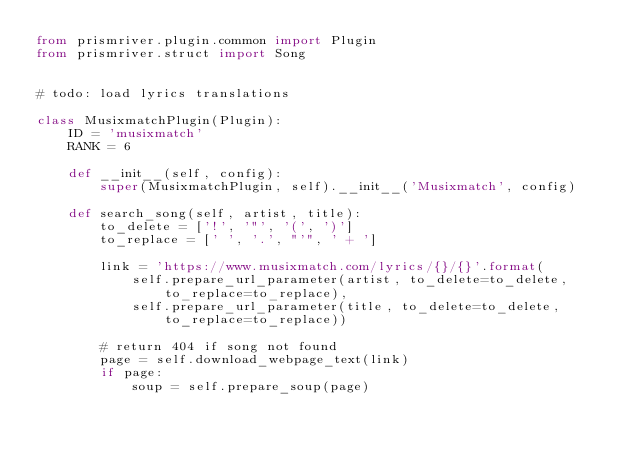Convert code to text. <code><loc_0><loc_0><loc_500><loc_500><_Python_>from prismriver.plugin.common import Plugin
from prismriver.struct import Song


# todo: load lyrics translations

class MusixmatchPlugin(Plugin):
    ID = 'musixmatch'
    RANK = 6

    def __init__(self, config):
        super(MusixmatchPlugin, self).__init__('Musixmatch', config)

    def search_song(self, artist, title):
        to_delete = ['!', '"', '(', ')']
        to_replace = [' ', '.', "'", ' + ']

        link = 'https://www.musixmatch.com/lyrics/{}/{}'.format(
            self.prepare_url_parameter(artist, to_delete=to_delete, to_replace=to_replace),
            self.prepare_url_parameter(title, to_delete=to_delete, to_replace=to_replace))

        # return 404 if song not found
        page = self.download_webpage_text(link)
        if page:
            soup = self.prepare_soup(page)
</code> 